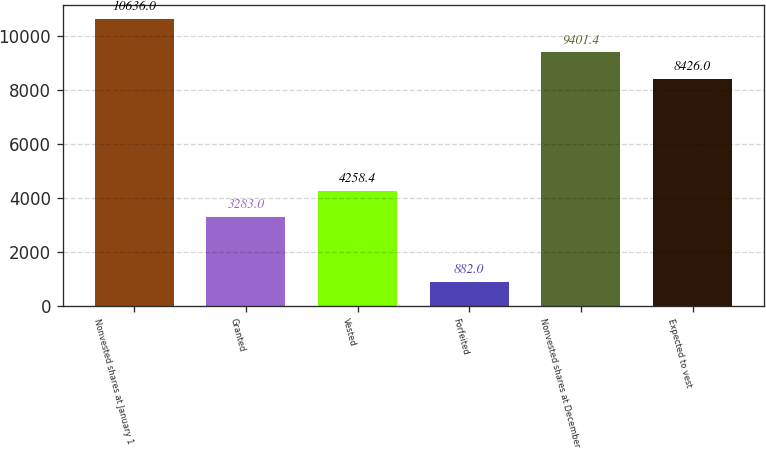Convert chart. <chart><loc_0><loc_0><loc_500><loc_500><bar_chart><fcel>Nonvested shares at January 1<fcel>Granted<fcel>Vested<fcel>Forfeited<fcel>Nonvested shares at December<fcel>Expected to vest<nl><fcel>10636<fcel>3283<fcel>4258.4<fcel>882<fcel>9401.4<fcel>8426<nl></chart> 